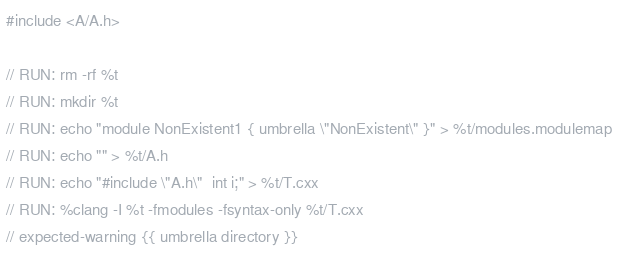<code> <loc_0><loc_0><loc_500><loc_500><_ObjectiveC_>#include <A/A.h>

// RUN: rm -rf %t
// RUN: mkdir %t
// RUN: echo "module NonExistent1 { umbrella \"NonExistent\" }" > %t/modules.modulemap
// RUN: echo "" > %t/A.h
// RUN: echo "#include \"A.h\"  int i;" > %t/T.cxx
// RUN: %clang -I %t -fmodules -fsyntax-only %t/T.cxx
// expected-warning {{ umbrella directory }}
</code> 